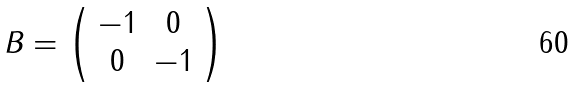<formula> <loc_0><loc_0><loc_500><loc_500>B = \left ( \begin{array} { c c } - 1 & 0 \\ 0 & - 1 \end{array} \right )</formula> 